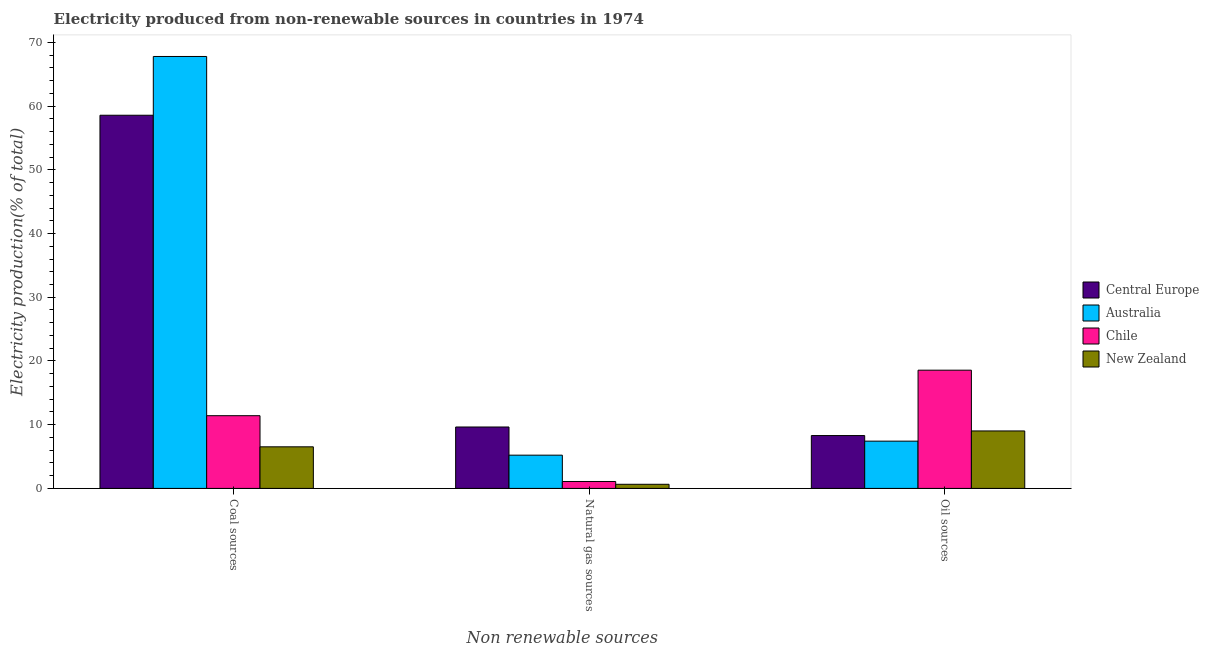How many different coloured bars are there?
Your response must be concise. 4. Are the number of bars per tick equal to the number of legend labels?
Keep it short and to the point. Yes. Are the number of bars on each tick of the X-axis equal?
Keep it short and to the point. Yes. How many bars are there on the 2nd tick from the left?
Your response must be concise. 4. How many bars are there on the 3rd tick from the right?
Provide a succinct answer. 4. What is the label of the 2nd group of bars from the left?
Your answer should be very brief. Natural gas sources. What is the percentage of electricity produced by oil sources in Chile?
Give a very brief answer. 18.55. Across all countries, what is the maximum percentage of electricity produced by oil sources?
Give a very brief answer. 18.55. Across all countries, what is the minimum percentage of electricity produced by oil sources?
Provide a succinct answer. 7.42. In which country was the percentage of electricity produced by oil sources maximum?
Offer a very short reply. Chile. In which country was the percentage of electricity produced by coal minimum?
Make the answer very short. New Zealand. What is the total percentage of electricity produced by coal in the graph?
Give a very brief answer. 144.28. What is the difference between the percentage of electricity produced by coal in New Zealand and that in Chile?
Give a very brief answer. -4.88. What is the difference between the percentage of electricity produced by oil sources in Central Europe and the percentage of electricity produced by natural gas in Australia?
Ensure brevity in your answer.  3.08. What is the average percentage of electricity produced by coal per country?
Offer a terse response. 36.07. What is the difference between the percentage of electricity produced by coal and percentage of electricity produced by natural gas in Chile?
Provide a succinct answer. 10.33. In how many countries, is the percentage of electricity produced by oil sources greater than 66 %?
Give a very brief answer. 0. What is the ratio of the percentage of electricity produced by natural gas in Central Europe to that in Chile?
Your answer should be compact. 8.87. What is the difference between the highest and the second highest percentage of electricity produced by oil sources?
Your answer should be compact. 9.54. What is the difference between the highest and the lowest percentage of electricity produced by natural gas?
Keep it short and to the point. 8.99. Is the sum of the percentage of electricity produced by coal in Australia and Central Europe greater than the maximum percentage of electricity produced by natural gas across all countries?
Your answer should be compact. Yes. What does the 4th bar from the left in Natural gas sources represents?
Your answer should be compact. New Zealand. What does the 4th bar from the right in Coal sources represents?
Offer a terse response. Central Europe. Are all the bars in the graph horizontal?
Your answer should be very brief. No. How many countries are there in the graph?
Give a very brief answer. 4. What is the difference between two consecutive major ticks on the Y-axis?
Provide a short and direct response. 10. Are the values on the major ticks of Y-axis written in scientific E-notation?
Provide a succinct answer. No. Does the graph contain any zero values?
Offer a very short reply. No. What is the title of the graph?
Ensure brevity in your answer.  Electricity produced from non-renewable sources in countries in 1974. What is the label or title of the X-axis?
Your answer should be compact. Non renewable sources. What is the label or title of the Y-axis?
Make the answer very short. Electricity production(% of total). What is the Electricity production(% of total) in Central Europe in Coal sources?
Provide a succinct answer. 58.56. What is the Electricity production(% of total) in Australia in Coal sources?
Offer a very short reply. 67.78. What is the Electricity production(% of total) in Chile in Coal sources?
Offer a terse response. 11.41. What is the Electricity production(% of total) in New Zealand in Coal sources?
Give a very brief answer. 6.53. What is the Electricity production(% of total) in Central Europe in Natural gas sources?
Provide a succinct answer. 9.64. What is the Electricity production(% of total) of Australia in Natural gas sources?
Offer a terse response. 5.22. What is the Electricity production(% of total) in Chile in Natural gas sources?
Give a very brief answer. 1.09. What is the Electricity production(% of total) of New Zealand in Natural gas sources?
Provide a succinct answer. 0.65. What is the Electricity production(% of total) of Central Europe in Oil sources?
Make the answer very short. 8.3. What is the Electricity production(% of total) of Australia in Oil sources?
Your response must be concise. 7.42. What is the Electricity production(% of total) in Chile in Oil sources?
Provide a short and direct response. 18.55. What is the Electricity production(% of total) in New Zealand in Oil sources?
Your response must be concise. 9.02. Across all Non renewable sources, what is the maximum Electricity production(% of total) of Central Europe?
Offer a very short reply. 58.56. Across all Non renewable sources, what is the maximum Electricity production(% of total) in Australia?
Ensure brevity in your answer.  67.78. Across all Non renewable sources, what is the maximum Electricity production(% of total) in Chile?
Provide a short and direct response. 18.55. Across all Non renewable sources, what is the maximum Electricity production(% of total) in New Zealand?
Your answer should be very brief. 9.02. Across all Non renewable sources, what is the minimum Electricity production(% of total) of Central Europe?
Offer a very short reply. 8.3. Across all Non renewable sources, what is the minimum Electricity production(% of total) in Australia?
Keep it short and to the point. 5.22. Across all Non renewable sources, what is the minimum Electricity production(% of total) in Chile?
Keep it short and to the point. 1.09. Across all Non renewable sources, what is the minimum Electricity production(% of total) of New Zealand?
Offer a very short reply. 0.65. What is the total Electricity production(% of total) in Central Europe in the graph?
Your answer should be compact. 76.5. What is the total Electricity production(% of total) in Australia in the graph?
Offer a terse response. 80.42. What is the total Electricity production(% of total) of Chile in the graph?
Offer a very short reply. 31.05. What is the total Electricity production(% of total) in New Zealand in the graph?
Keep it short and to the point. 16.19. What is the difference between the Electricity production(% of total) in Central Europe in Coal sources and that in Natural gas sources?
Make the answer very short. 48.92. What is the difference between the Electricity production(% of total) in Australia in Coal sources and that in Natural gas sources?
Provide a succinct answer. 62.56. What is the difference between the Electricity production(% of total) of Chile in Coal sources and that in Natural gas sources?
Offer a terse response. 10.33. What is the difference between the Electricity production(% of total) in New Zealand in Coal sources and that in Natural gas sources?
Give a very brief answer. 5.88. What is the difference between the Electricity production(% of total) of Central Europe in Coal sources and that in Oil sources?
Provide a succinct answer. 50.27. What is the difference between the Electricity production(% of total) in Australia in Coal sources and that in Oil sources?
Make the answer very short. 60.37. What is the difference between the Electricity production(% of total) in Chile in Coal sources and that in Oil sources?
Your answer should be compact. -7.14. What is the difference between the Electricity production(% of total) in New Zealand in Coal sources and that in Oil sources?
Offer a terse response. -2.49. What is the difference between the Electricity production(% of total) of Central Europe in Natural gas sources and that in Oil sources?
Your response must be concise. 1.34. What is the difference between the Electricity production(% of total) in Australia in Natural gas sources and that in Oil sources?
Give a very brief answer. -2.2. What is the difference between the Electricity production(% of total) in Chile in Natural gas sources and that in Oil sources?
Provide a succinct answer. -17.47. What is the difference between the Electricity production(% of total) of New Zealand in Natural gas sources and that in Oil sources?
Your response must be concise. -8.37. What is the difference between the Electricity production(% of total) of Central Europe in Coal sources and the Electricity production(% of total) of Australia in Natural gas sources?
Keep it short and to the point. 53.34. What is the difference between the Electricity production(% of total) of Central Europe in Coal sources and the Electricity production(% of total) of Chile in Natural gas sources?
Ensure brevity in your answer.  57.48. What is the difference between the Electricity production(% of total) in Central Europe in Coal sources and the Electricity production(% of total) in New Zealand in Natural gas sources?
Offer a terse response. 57.91. What is the difference between the Electricity production(% of total) of Australia in Coal sources and the Electricity production(% of total) of Chile in Natural gas sources?
Your answer should be compact. 66.7. What is the difference between the Electricity production(% of total) in Australia in Coal sources and the Electricity production(% of total) in New Zealand in Natural gas sources?
Ensure brevity in your answer.  67.14. What is the difference between the Electricity production(% of total) in Chile in Coal sources and the Electricity production(% of total) in New Zealand in Natural gas sources?
Keep it short and to the point. 10.76. What is the difference between the Electricity production(% of total) of Central Europe in Coal sources and the Electricity production(% of total) of Australia in Oil sources?
Your answer should be very brief. 51.14. What is the difference between the Electricity production(% of total) in Central Europe in Coal sources and the Electricity production(% of total) in Chile in Oil sources?
Ensure brevity in your answer.  40.01. What is the difference between the Electricity production(% of total) of Central Europe in Coal sources and the Electricity production(% of total) of New Zealand in Oil sources?
Give a very brief answer. 49.54. What is the difference between the Electricity production(% of total) of Australia in Coal sources and the Electricity production(% of total) of Chile in Oil sources?
Keep it short and to the point. 49.23. What is the difference between the Electricity production(% of total) of Australia in Coal sources and the Electricity production(% of total) of New Zealand in Oil sources?
Your response must be concise. 58.76. What is the difference between the Electricity production(% of total) in Chile in Coal sources and the Electricity production(% of total) in New Zealand in Oil sources?
Ensure brevity in your answer.  2.39. What is the difference between the Electricity production(% of total) of Central Europe in Natural gas sources and the Electricity production(% of total) of Australia in Oil sources?
Your answer should be compact. 2.22. What is the difference between the Electricity production(% of total) in Central Europe in Natural gas sources and the Electricity production(% of total) in Chile in Oil sources?
Your response must be concise. -8.92. What is the difference between the Electricity production(% of total) of Central Europe in Natural gas sources and the Electricity production(% of total) of New Zealand in Oil sources?
Offer a very short reply. 0.62. What is the difference between the Electricity production(% of total) of Australia in Natural gas sources and the Electricity production(% of total) of Chile in Oil sources?
Your answer should be very brief. -13.34. What is the difference between the Electricity production(% of total) in Australia in Natural gas sources and the Electricity production(% of total) in New Zealand in Oil sources?
Offer a terse response. -3.8. What is the difference between the Electricity production(% of total) in Chile in Natural gas sources and the Electricity production(% of total) in New Zealand in Oil sources?
Offer a very short reply. -7.93. What is the average Electricity production(% of total) in Central Europe per Non renewable sources?
Keep it short and to the point. 25.5. What is the average Electricity production(% of total) of Australia per Non renewable sources?
Offer a very short reply. 26.81. What is the average Electricity production(% of total) of Chile per Non renewable sources?
Provide a succinct answer. 10.35. What is the average Electricity production(% of total) in New Zealand per Non renewable sources?
Make the answer very short. 5.4. What is the difference between the Electricity production(% of total) of Central Europe and Electricity production(% of total) of Australia in Coal sources?
Your answer should be very brief. -9.22. What is the difference between the Electricity production(% of total) of Central Europe and Electricity production(% of total) of Chile in Coal sources?
Ensure brevity in your answer.  47.15. What is the difference between the Electricity production(% of total) in Central Europe and Electricity production(% of total) in New Zealand in Coal sources?
Offer a terse response. 52.03. What is the difference between the Electricity production(% of total) of Australia and Electricity production(% of total) of Chile in Coal sources?
Your answer should be compact. 56.37. What is the difference between the Electricity production(% of total) of Australia and Electricity production(% of total) of New Zealand in Coal sources?
Provide a short and direct response. 61.26. What is the difference between the Electricity production(% of total) of Chile and Electricity production(% of total) of New Zealand in Coal sources?
Your answer should be compact. 4.88. What is the difference between the Electricity production(% of total) of Central Europe and Electricity production(% of total) of Australia in Natural gas sources?
Offer a very short reply. 4.42. What is the difference between the Electricity production(% of total) in Central Europe and Electricity production(% of total) in Chile in Natural gas sources?
Give a very brief answer. 8.55. What is the difference between the Electricity production(% of total) in Central Europe and Electricity production(% of total) in New Zealand in Natural gas sources?
Provide a short and direct response. 8.99. What is the difference between the Electricity production(% of total) in Australia and Electricity production(% of total) in Chile in Natural gas sources?
Ensure brevity in your answer.  4.13. What is the difference between the Electricity production(% of total) in Australia and Electricity production(% of total) in New Zealand in Natural gas sources?
Offer a terse response. 4.57. What is the difference between the Electricity production(% of total) in Chile and Electricity production(% of total) in New Zealand in Natural gas sources?
Offer a very short reply. 0.44. What is the difference between the Electricity production(% of total) of Central Europe and Electricity production(% of total) of Australia in Oil sources?
Your answer should be very brief. 0.88. What is the difference between the Electricity production(% of total) of Central Europe and Electricity production(% of total) of Chile in Oil sources?
Your response must be concise. -10.26. What is the difference between the Electricity production(% of total) of Central Europe and Electricity production(% of total) of New Zealand in Oil sources?
Offer a terse response. -0.72. What is the difference between the Electricity production(% of total) in Australia and Electricity production(% of total) in Chile in Oil sources?
Your response must be concise. -11.14. What is the difference between the Electricity production(% of total) of Australia and Electricity production(% of total) of New Zealand in Oil sources?
Give a very brief answer. -1.6. What is the difference between the Electricity production(% of total) in Chile and Electricity production(% of total) in New Zealand in Oil sources?
Your answer should be compact. 9.54. What is the ratio of the Electricity production(% of total) in Central Europe in Coal sources to that in Natural gas sources?
Offer a very short reply. 6.08. What is the ratio of the Electricity production(% of total) in Australia in Coal sources to that in Natural gas sources?
Ensure brevity in your answer.  12.99. What is the ratio of the Electricity production(% of total) of Chile in Coal sources to that in Natural gas sources?
Your answer should be very brief. 10.51. What is the ratio of the Electricity production(% of total) in New Zealand in Coal sources to that in Natural gas sources?
Your response must be concise. 10.07. What is the ratio of the Electricity production(% of total) in Central Europe in Coal sources to that in Oil sources?
Your answer should be compact. 7.06. What is the ratio of the Electricity production(% of total) of Australia in Coal sources to that in Oil sources?
Ensure brevity in your answer.  9.14. What is the ratio of the Electricity production(% of total) in Chile in Coal sources to that in Oil sources?
Offer a very short reply. 0.62. What is the ratio of the Electricity production(% of total) of New Zealand in Coal sources to that in Oil sources?
Provide a short and direct response. 0.72. What is the ratio of the Electricity production(% of total) of Central Europe in Natural gas sources to that in Oil sources?
Make the answer very short. 1.16. What is the ratio of the Electricity production(% of total) in Australia in Natural gas sources to that in Oil sources?
Ensure brevity in your answer.  0.7. What is the ratio of the Electricity production(% of total) of Chile in Natural gas sources to that in Oil sources?
Your answer should be very brief. 0.06. What is the ratio of the Electricity production(% of total) of New Zealand in Natural gas sources to that in Oil sources?
Keep it short and to the point. 0.07. What is the difference between the highest and the second highest Electricity production(% of total) of Central Europe?
Your response must be concise. 48.92. What is the difference between the highest and the second highest Electricity production(% of total) in Australia?
Keep it short and to the point. 60.37. What is the difference between the highest and the second highest Electricity production(% of total) in Chile?
Offer a terse response. 7.14. What is the difference between the highest and the second highest Electricity production(% of total) of New Zealand?
Ensure brevity in your answer.  2.49. What is the difference between the highest and the lowest Electricity production(% of total) of Central Europe?
Make the answer very short. 50.27. What is the difference between the highest and the lowest Electricity production(% of total) in Australia?
Provide a short and direct response. 62.56. What is the difference between the highest and the lowest Electricity production(% of total) in Chile?
Make the answer very short. 17.47. What is the difference between the highest and the lowest Electricity production(% of total) of New Zealand?
Provide a succinct answer. 8.37. 